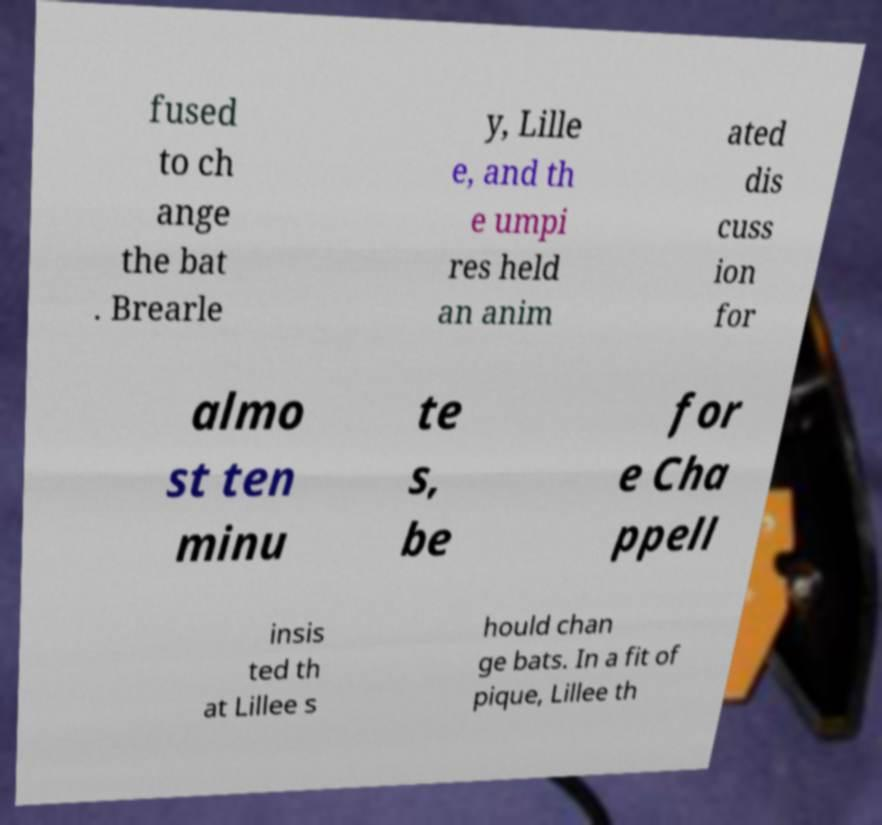Please read and relay the text visible in this image. What does it say? fused to ch ange the bat . Brearle y, Lille e, and th e umpi res held an anim ated dis cuss ion for almo st ten minu te s, be for e Cha ppell insis ted th at Lillee s hould chan ge bats. In a fit of pique, Lillee th 